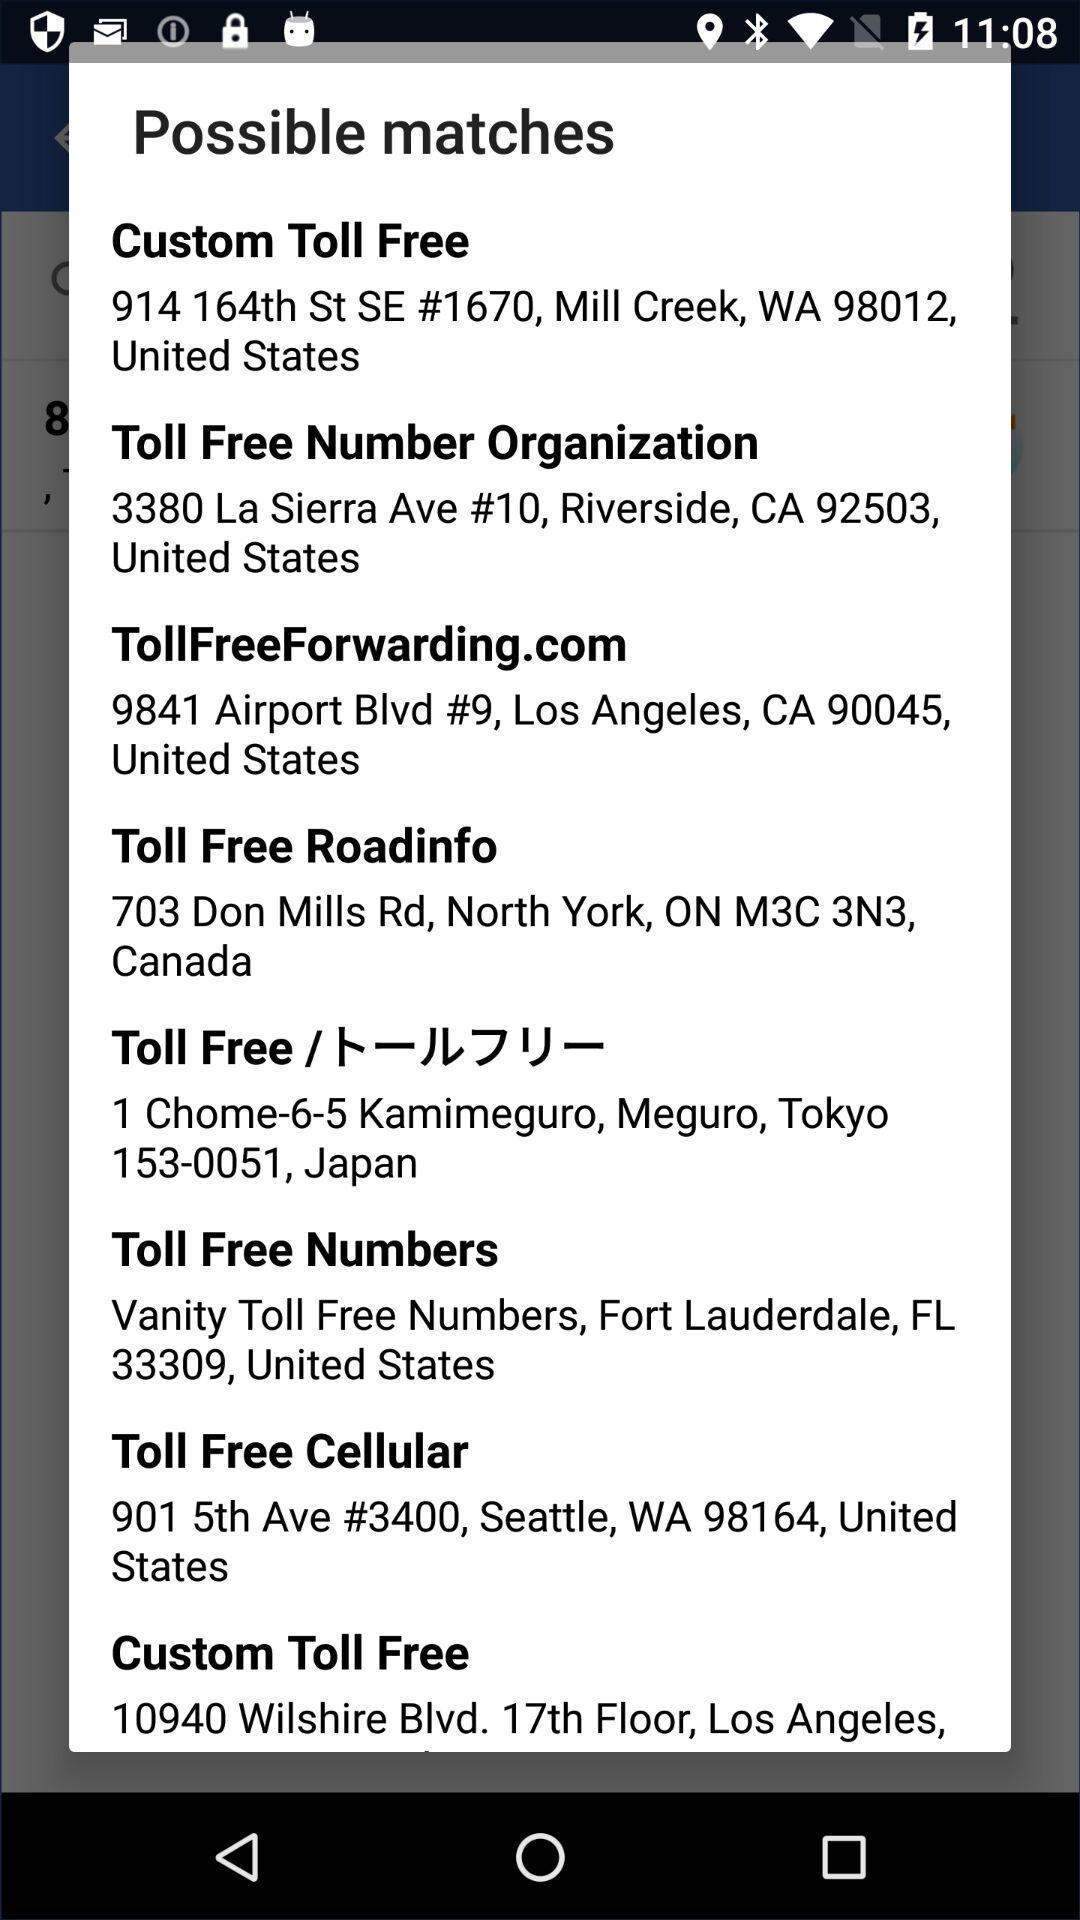What is the toll-free cellular address? The address is 901 5th Ave, #3400, Seattle, WA 98164, United States. 